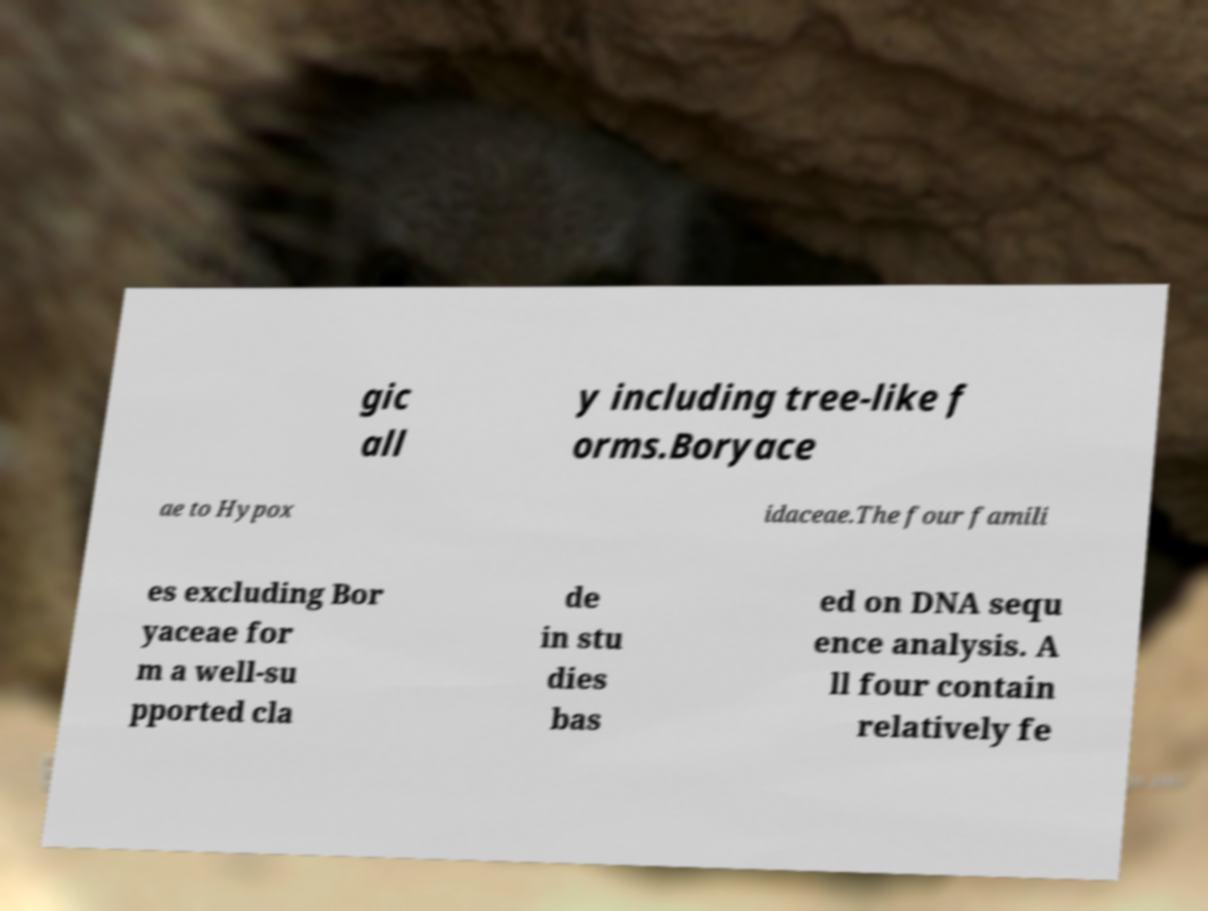I need the written content from this picture converted into text. Can you do that? gic all y including tree-like f orms.Boryace ae to Hypox idaceae.The four famili es excluding Bor yaceae for m a well-su pported cla de in stu dies bas ed on DNA sequ ence analysis. A ll four contain relatively fe 